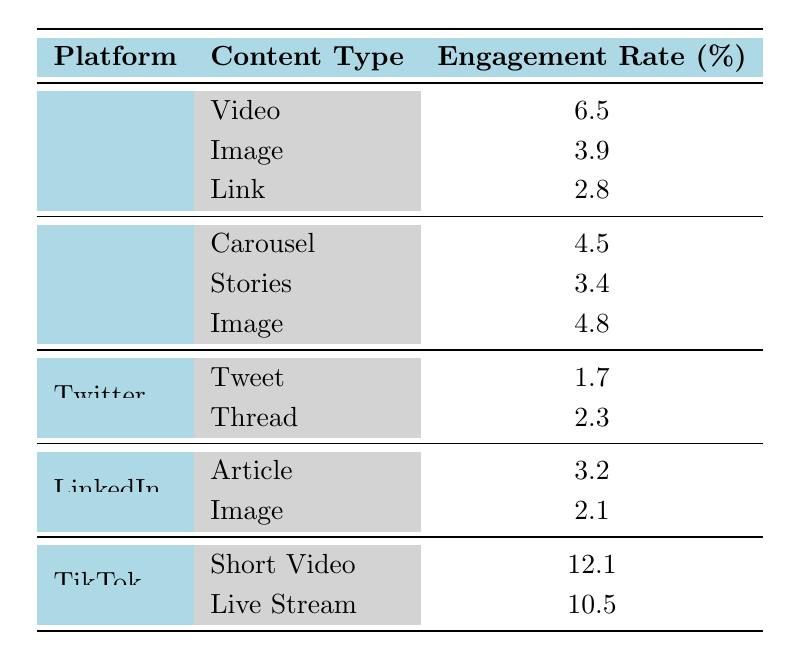What is the engagement rate for video content on Facebook? The table lists the engagement rate for video on Facebook as 6.5%.
Answer: 6.5 Which platform has the highest engagement rate for content type and what is that engagement rate? TikTok has the highest engagement rate for content type, specifically for short video at 12.1%.
Answer: TikTok, 12.1 What is the average engagement rate for image content across all platforms? Summing the engagement rates for image content: Facebook (3.9) + Instagram (4.8) + LinkedIn (2.1) = 10.8. There are three image entries, so the average is 10.8/3 = 3.6.
Answer: 3.6 Is the engagement rate for tweets on Twitter greater than that for links on Facebook? The engagement rate for tweets on Twitter is 1.7%, which is less than that for links on Facebook at 2.8%. Therefore, this statement is false.
Answer: No What is the combined engagement rate of all content types on TikTok? For TikTok, add the engagement rates for both content types: Short Video (12.1) + Live Stream (10.5) = 22.6.
Answer: 22.6 Does Instagram have a higher average engagement rate for content types compared to Twitter? For Instagram: (4.5 + 3.4 + 4.8) / 3 = 4.23. For Twitter: (1.7 + 2.3) / 2 = 2.0. Since 4.23 is greater than 2.0, the statement is true.
Answer: Yes What content type on Instagram has the lowest engagement rate? Among the content types listed for Instagram, the engagement rate of Stories (3.4) is the lowest.
Answer: Stories, 3.4 Which platform has the lowest overall engagement rate across all its content types? Considering the engagement rates: Facebook (6.5, 3.9, 2.8), Instagram (4.5, 3.4, 4.8), Twitter (1.7, 2.3), LinkedIn (3.2, 2.1), and TikTok (12.1, 10.5), Twitter has the lowest average engagement at (1.7 + 2.3) / 2 = 2.0.
Answer: Twitter 